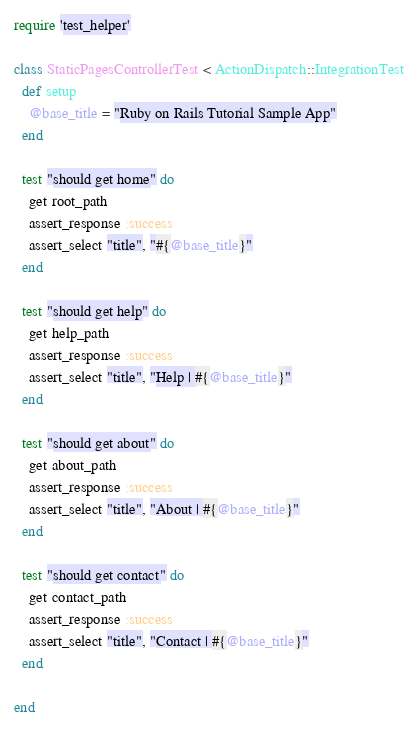<code> <loc_0><loc_0><loc_500><loc_500><_Ruby_>require 'test_helper'

class StaticPagesControllerTest < ActionDispatch::IntegrationTest
  def setup
    @base_title = "Ruby on Rails Tutorial Sample App"
  end
  
  test "should get home" do
    get root_path
    assert_response :success
    assert_select "title", "#{@base_title}"
  end

  test "should get help" do
    get help_path
    assert_response :success
    assert_select "title", "Help | #{@base_title}"
  end
  
  test "should get about" do
    get about_path
    assert_response :success
    assert_select "title", "About | #{@base_title}"
  end
  
  test "should get contact" do
    get contact_path
    assert_response :success
    assert_select "title", "Contact | #{@base_title}"
  end

end
</code> 